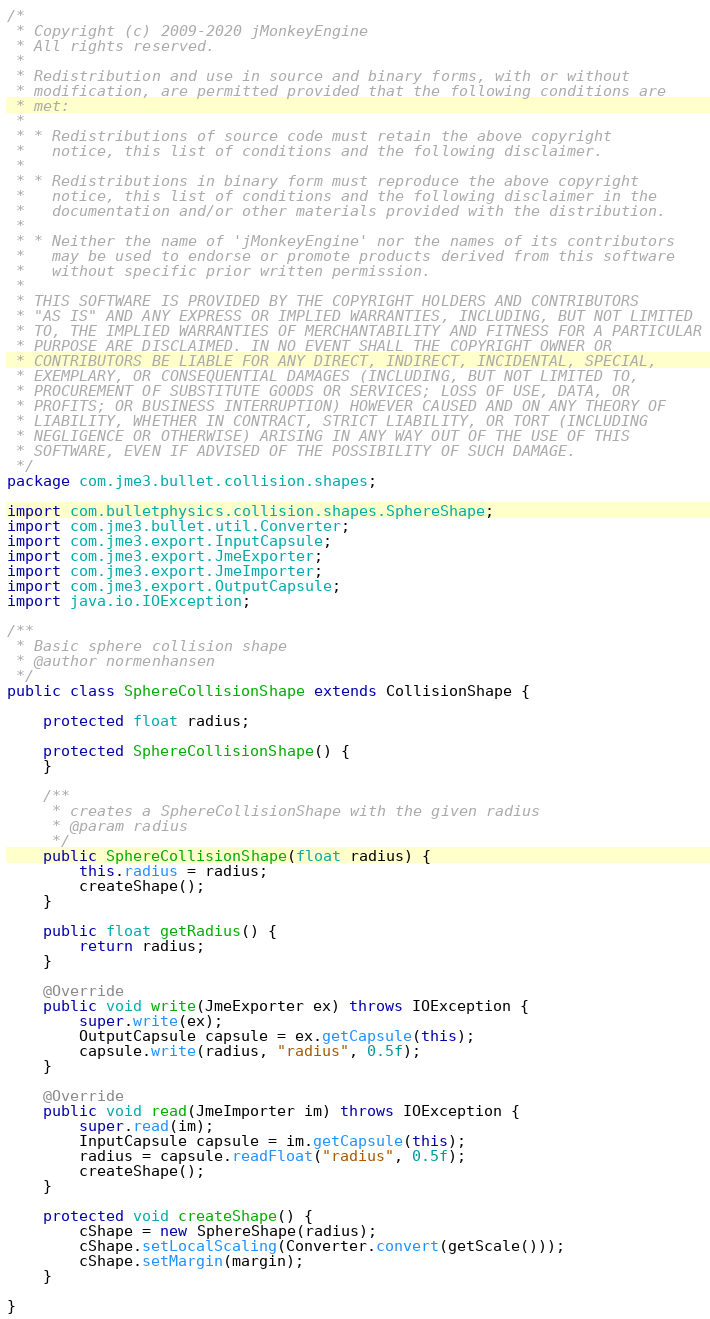Convert code to text. <code><loc_0><loc_0><loc_500><loc_500><_Java_>/*
 * Copyright (c) 2009-2020 jMonkeyEngine
 * All rights reserved.
 *
 * Redistribution and use in source and binary forms, with or without
 * modification, are permitted provided that the following conditions are
 * met:
 *
 * * Redistributions of source code must retain the above copyright
 *   notice, this list of conditions and the following disclaimer.
 *
 * * Redistributions in binary form must reproduce the above copyright
 *   notice, this list of conditions and the following disclaimer in the
 *   documentation and/or other materials provided with the distribution.
 *
 * * Neither the name of 'jMonkeyEngine' nor the names of its contributors
 *   may be used to endorse or promote products derived from this software
 *   without specific prior written permission.
 *
 * THIS SOFTWARE IS PROVIDED BY THE COPYRIGHT HOLDERS AND CONTRIBUTORS
 * "AS IS" AND ANY EXPRESS OR IMPLIED WARRANTIES, INCLUDING, BUT NOT LIMITED
 * TO, THE IMPLIED WARRANTIES OF MERCHANTABILITY AND FITNESS FOR A PARTICULAR
 * PURPOSE ARE DISCLAIMED. IN NO EVENT SHALL THE COPYRIGHT OWNER OR
 * CONTRIBUTORS BE LIABLE FOR ANY DIRECT, INDIRECT, INCIDENTAL, SPECIAL,
 * EXEMPLARY, OR CONSEQUENTIAL DAMAGES (INCLUDING, BUT NOT LIMITED TO,
 * PROCUREMENT OF SUBSTITUTE GOODS OR SERVICES; LOSS OF USE, DATA, OR
 * PROFITS; OR BUSINESS INTERRUPTION) HOWEVER CAUSED AND ON ANY THEORY OF
 * LIABILITY, WHETHER IN CONTRACT, STRICT LIABILITY, OR TORT (INCLUDING
 * NEGLIGENCE OR OTHERWISE) ARISING IN ANY WAY OUT OF THE USE OF THIS
 * SOFTWARE, EVEN IF ADVISED OF THE POSSIBILITY OF SUCH DAMAGE.
 */
package com.jme3.bullet.collision.shapes;

import com.bulletphysics.collision.shapes.SphereShape;
import com.jme3.bullet.util.Converter;
import com.jme3.export.InputCapsule;
import com.jme3.export.JmeExporter;
import com.jme3.export.JmeImporter;
import com.jme3.export.OutputCapsule;
import java.io.IOException;

/**
 * Basic sphere collision shape
 * @author normenhansen
 */
public class SphereCollisionShape extends CollisionShape {

    protected float radius;

    protected SphereCollisionShape() {
    }

    /**
     * creates a SphereCollisionShape with the given radius
     * @param radius
     */
    public SphereCollisionShape(float radius) {
        this.radius = radius;
        createShape();
    }

    public float getRadius() {
        return radius;
    }

    @Override
    public void write(JmeExporter ex) throws IOException {
        super.write(ex);
        OutputCapsule capsule = ex.getCapsule(this);
        capsule.write(radius, "radius", 0.5f);
    }

    @Override
    public void read(JmeImporter im) throws IOException {
        super.read(im);
        InputCapsule capsule = im.getCapsule(this);
        radius = capsule.readFloat("radius", 0.5f);
        createShape();
    }

    protected void createShape() {
        cShape = new SphereShape(radius);
        cShape.setLocalScaling(Converter.convert(getScale()));
        cShape.setMargin(margin);
    }

}
</code> 